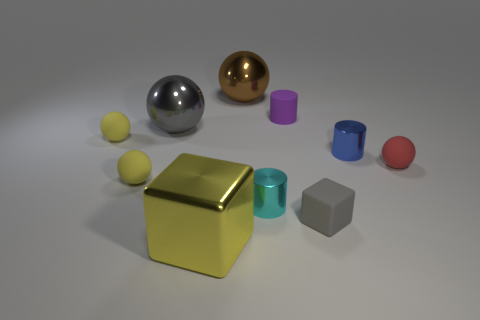There is a cube that is made of the same material as the small red object; what color is it?
Offer a terse response. Gray. Are there more tiny yellow balls than brown things?
Offer a very short reply. Yes. What size is the matte object that is both on the left side of the large yellow block and behind the blue metallic object?
Keep it short and to the point. Small. There is a large thing that is the same color as the tiny matte cube; what is it made of?
Ensure brevity in your answer.  Metal. Is the number of matte blocks to the left of the tiny matte cylinder the same as the number of green cubes?
Give a very brief answer. Yes. Does the purple matte thing have the same size as the gray sphere?
Give a very brief answer. No. What color is the object that is both to the left of the gray matte object and in front of the cyan shiny cylinder?
Provide a succinct answer. Yellow. What material is the block on the right side of the cube that is on the left side of the small cyan object?
Provide a short and direct response. Rubber. What size is the red thing that is the same shape as the gray shiny object?
Give a very brief answer. Small. There is a metallic cylinder right of the cyan shiny cylinder; does it have the same color as the matte cube?
Your answer should be compact. No. 